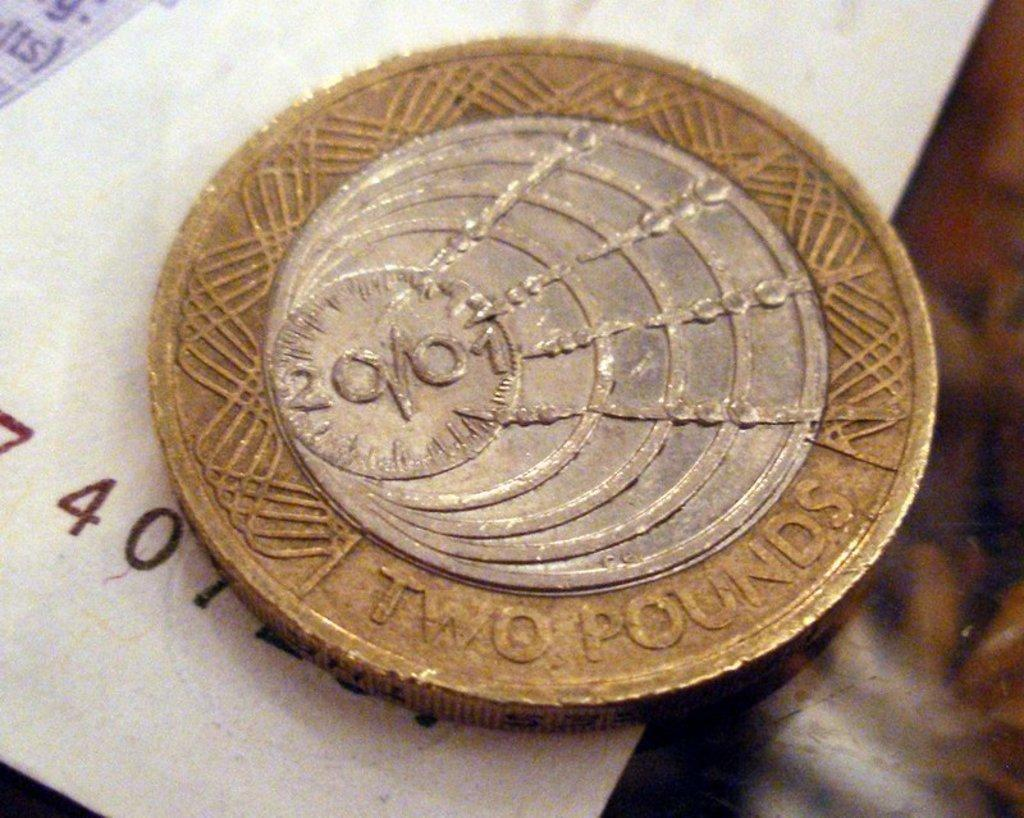<image>
Present a compact description of the photo's key features. The silver and gold coins shown is a British two pounds coin. 